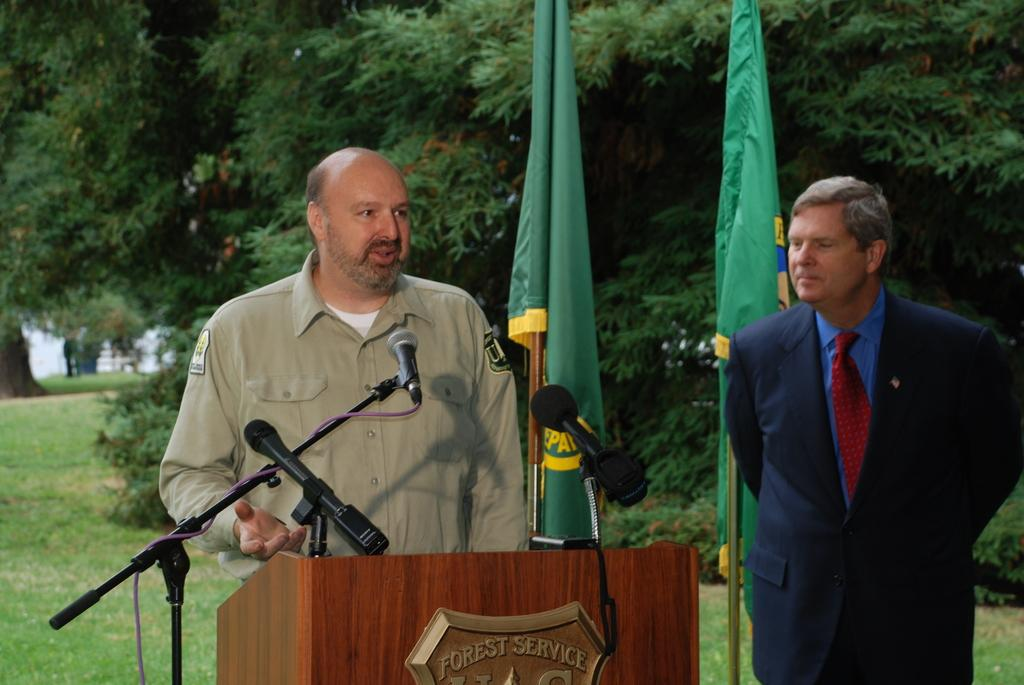What is the primary subject in the image? There is a person standing in the image. What is in front of the person? There is a table in front of the person. What is on the table? There are mice on the table. Is there anyone else in the image? Yes, there is another person standing beside the first person. What else can be seen in the image? There are flags visible in the image. What is visible in the background of the image? There are trees in the background of the image. What type of needle is being used by the person in the image? There is no needle present in the image. What agreement was reached between the two people in the image? There is no indication of an agreement or discussion between the two people in the image. 